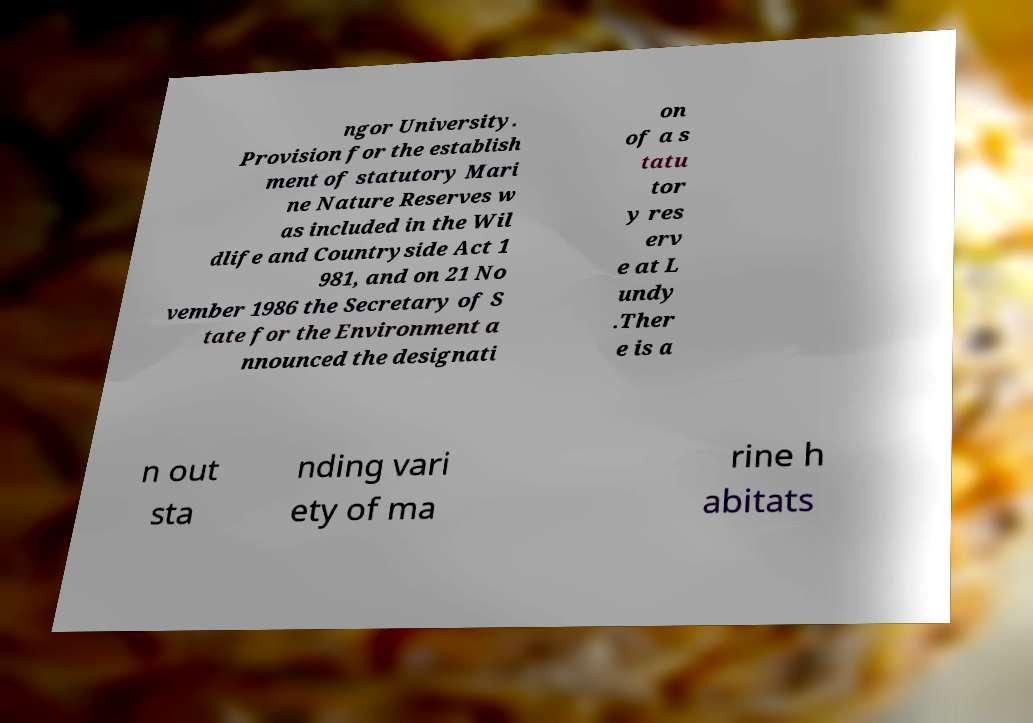What messages or text are displayed in this image? I need them in a readable, typed format. ngor University. Provision for the establish ment of statutory Mari ne Nature Reserves w as included in the Wil dlife and Countryside Act 1 981, and on 21 No vember 1986 the Secretary of S tate for the Environment a nnounced the designati on of a s tatu tor y res erv e at L undy .Ther e is a n out sta nding vari ety of ma rine h abitats 